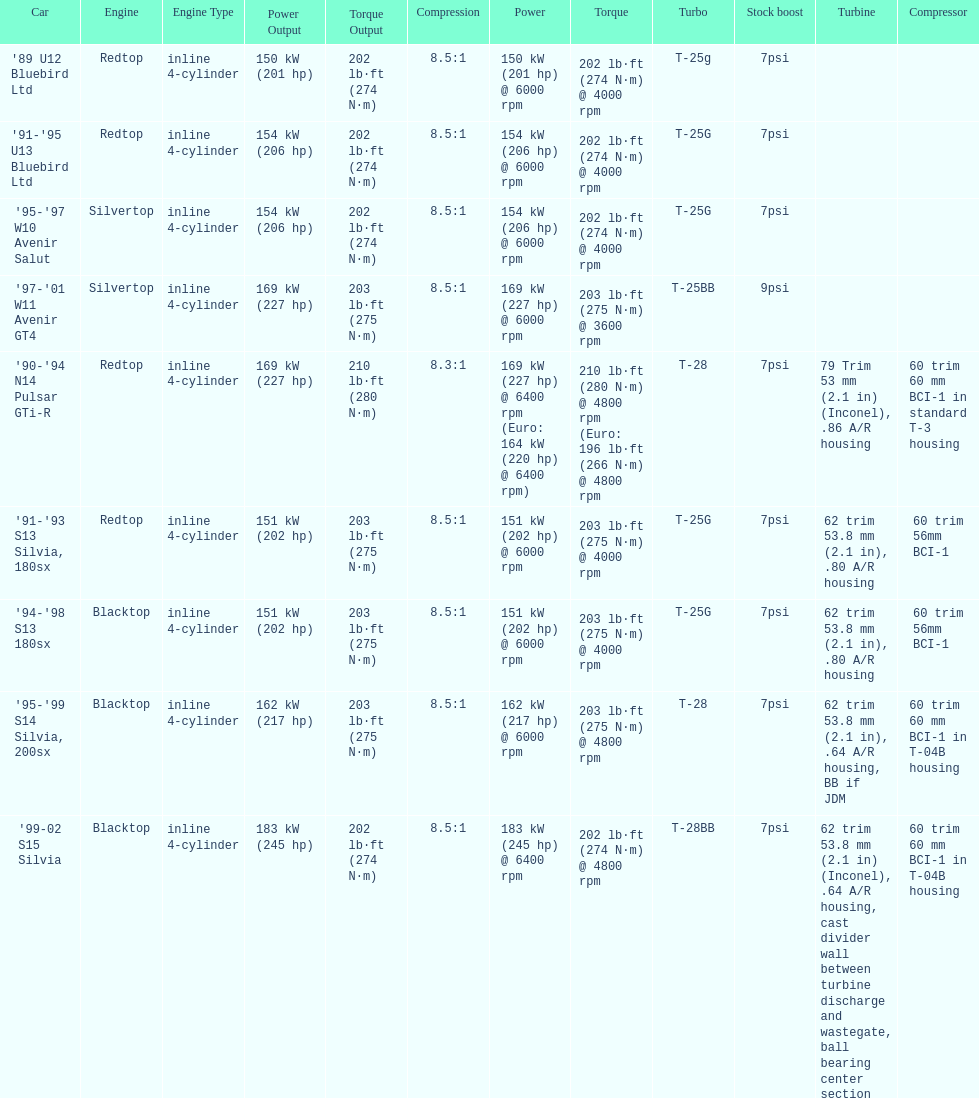Which engines are the same as the first entry ('89 u12 bluebird ltd)? '91-'95 U13 Bluebird Ltd, '90-'94 N14 Pulsar GTi-R, '91-'93 S13 Silvia, 180sx. 